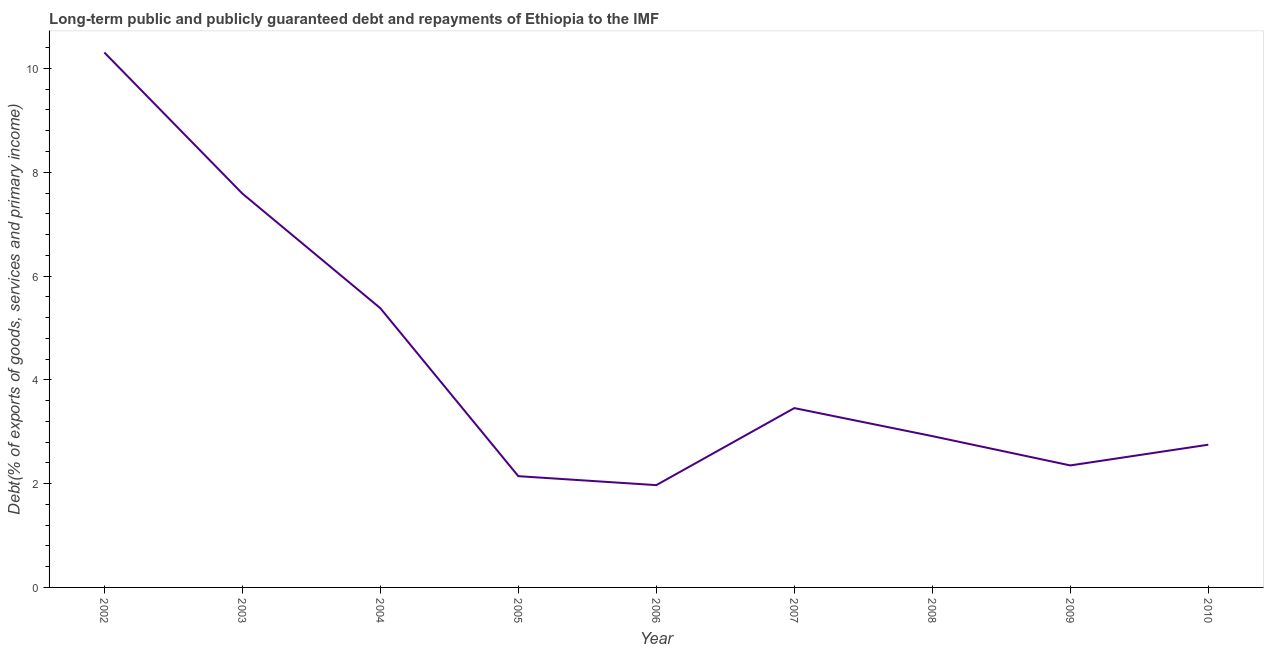What is the debt service in 2008?
Offer a terse response. 2.92. Across all years, what is the maximum debt service?
Make the answer very short. 10.31. Across all years, what is the minimum debt service?
Your answer should be very brief. 1.97. What is the sum of the debt service?
Provide a succinct answer. 38.87. What is the difference between the debt service in 2003 and 2009?
Provide a succinct answer. 5.24. What is the average debt service per year?
Your answer should be compact. 4.32. What is the median debt service?
Your response must be concise. 2.92. What is the ratio of the debt service in 2006 to that in 2009?
Keep it short and to the point. 0.84. What is the difference between the highest and the second highest debt service?
Give a very brief answer. 2.72. Is the sum of the debt service in 2005 and 2008 greater than the maximum debt service across all years?
Your answer should be compact. No. What is the difference between the highest and the lowest debt service?
Offer a terse response. 8.34. In how many years, is the debt service greater than the average debt service taken over all years?
Provide a short and direct response. 3. How many lines are there?
Provide a succinct answer. 1. How many years are there in the graph?
Give a very brief answer. 9. Are the values on the major ticks of Y-axis written in scientific E-notation?
Provide a short and direct response. No. Does the graph contain any zero values?
Offer a very short reply. No. What is the title of the graph?
Provide a succinct answer. Long-term public and publicly guaranteed debt and repayments of Ethiopia to the IMF. What is the label or title of the Y-axis?
Ensure brevity in your answer.  Debt(% of exports of goods, services and primary income). What is the Debt(% of exports of goods, services and primary income) of 2002?
Ensure brevity in your answer.  10.31. What is the Debt(% of exports of goods, services and primary income) of 2003?
Offer a very short reply. 7.59. What is the Debt(% of exports of goods, services and primary income) in 2004?
Offer a terse response. 5.38. What is the Debt(% of exports of goods, services and primary income) of 2005?
Make the answer very short. 2.14. What is the Debt(% of exports of goods, services and primary income) of 2006?
Ensure brevity in your answer.  1.97. What is the Debt(% of exports of goods, services and primary income) of 2007?
Keep it short and to the point. 3.46. What is the Debt(% of exports of goods, services and primary income) in 2008?
Provide a succinct answer. 2.92. What is the Debt(% of exports of goods, services and primary income) of 2009?
Your answer should be compact. 2.35. What is the Debt(% of exports of goods, services and primary income) in 2010?
Your answer should be very brief. 2.75. What is the difference between the Debt(% of exports of goods, services and primary income) in 2002 and 2003?
Offer a very short reply. 2.72. What is the difference between the Debt(% of exports of goods, services and primary income) in 2002 and 2004?
Provide a short and direct response. 4.93. What is the difference between the Debt(% of exports of goods, services and primary income) in 2002 and 2005?
Keep it short and to the point. 8.16. What is the difference between the Debt(% of exports of goods, services and primary income) in 2002 and 2006?
Provide a succinct answer. 8.34. What is the difference between the Debt(% of exports of goods, services and primary income) in 2002 and 2007?
Offer a terse response. 6.85. What is the difference between the Debt(% of exports of goods, services and primary income) in 2002 and 2008?
Provide a short and direct response. 7.39. What is the difference between the Debt(% of exports of goods, services and primary income) in 2002 and 2009?
Ensure brevity in your answer.  7.96. What is the difference between the Debt(% of exports of goods, services and primary income) in 2002 and 2010?
Your response must be concise. 7.56. What is the difference between the Debt(% of exports of goods, services and primary income) in 2003 and 2004?
Make the answer very short. 2.21. What is the difference between the Debt(% of exports of goods, services and primary income) in 2003 and 2005?
Ensure brevity in your answer.  5.45. What is the difference between the Debt(% of exports of goods, services and primary income) in 2003 and 2006?
Offer a very short reply. 5.62. What is the difference between the Debt(% of exports of goods, services and primary income) in 2003 and 2007?
Provide a short and direct response. 4.13. What is the difference between the Debt(% of exports of goods, services and primary income) in 2003 and 2008?
Your response must be concise. 4.67. What is the difference between the Debt(% of exports of goods, services and primary income) in 2003 and 2009?
Give a very brief answer. 5.24. What is the difference between the Debt(% of exports of goods, services and primary income) in 2003 and 2010?
Provide a succinct answer. 4.84. What is the difference between the Debt(% of exports of goods, services and primary income) in 2004 and 2005?
Your response must be concise. 3.24. What is the difference between the Debt(% of exports of goods, services and primary income) in 2004 and 2006?
Provide a succinct answer. 3.41. What is the difference between the Debt(% of exports of goods, services and primary income) in 2004 and 2007?
Offer a very short reply. 1.92. What is the difference between the Debt(% of exports of goods, services and primary income) in 2004 and 2008?
Provide a short and direct response. 2.46. What is the difference between the Debt(% of exports of goods, services and primary income) in 2004 and 2009?
Provide a short and direct response. 3.03. What is the difference between the Debt(% of exports of goods, services and primary income) in 2004 and 2010?
Ensure brevity in your answer.  2.63. What is the difference between the Debt(% of exports of goods, services and primary income) in 2005 and 2006?
Keep it short and to the point. 0.17. What is the difference between the Debt(% of exports of goods, services and primary income) in 2005 and 2007?
Keep it short and to the point. -1.31. What is the difference between the Debt(% of exports of goods, services and primary income) in 2005 and 2008?
Offer a terse response. -0.77. What is the difference between the Debt(% of exports of goods, services and primary income) in 2005 and 2009?
Your answer should be compact. -0.21. What is the difference between the Debt(% of exports of goods, services and primary income) in 2005 and 2010?
Give a very brief answer. -0.61. What is the difference between the Debt(% of exports of goods, services and primary income) in 2006 and 2007?
Your response must be concise. -1.48. What is the difference between the Debt(% of exports of goods, services and primary income) in 2006 and 2008?
Keep it short and to the point. -0.94. What is the difference between the Debt(% of exports of goods, services and primary income) in 2006 and 2009?
Provide a succinct answer. -0.38. What is the difference between the Debt(% of exports of goods, services and primary income) in 2006 and 2010?
Provide a short and direct response. -0.78. What is the difference between the Debt(% of exports of goods, services and primary income) in 2007 and 2008?
Offer a very short reply. 0.54. What is the difference between the Debt(% of exports of goods, services and primary income) in 2007 and 2009?
Offer a very short reply. 1.1. What is the difference between the Debt(% of exports of goods, services and primary income) in 2007 and 2010?
Ensure brevity in your answer.  0.71. What is the difference between the Debt(% of exports of goods, services and primary income) in 2008 and 2009?
Your answer should be very brief. 0.56. What is the difference between the Debt(% of exports of goods, services and primary income) in 2008 and 2010?
Your answer should be very brief. 0.17. What is the difference between the Debt(% of exports of goods, services and primary income) in 2009 and 2010?
Make the answer very short. -0.4. What is the ratio of the Debt(% of exports of goods, services and primary income) in 2002 to that in 2003?
Offer a very short reply. 1.36. What is the ratio of the Debt(% of exports of goods, services and primary income) in 2002 to that in 2004?
Provide a succinct answer. 1.92. What is the ratio of the Debt(% of exports of goods, services and primary income) in 2002 to that in 2005?
Offer a terse response. 4.81. What is the ratio of the Debt(% of exports of goods, services and primary income) in 2002 to that in 2006?
Keep it short and to the point. 5.23. What is the ratio of the Debt(% of exports of goods, services and primary income) in 2002 to that in 2007?
Make the answer very short. 2.98. What is the ratio of the Debt(% of exports of goods, services and primary income) in 2002 to that in 2008?
Offer a terse response. 3.54. What is the ratio of the Debt(% of exports of goods, services and primary income) in 2002 to that in 2009?
Make the answer very short. 4.38. What is the ratio of the Debt(% of exports of goods, services and primary income) in 2002 to that in 2010?
Offer a very short reply. 3.75. What is the ratio of the Debt(% of exports of goods, services and primary income) in 2003 to that in 2004?
Offer a terse response. 1.41. What is the ratio of the Debt(% of exports of goods, services and primary income) in 2003 to that in 2005?
Your answer should be compact. 3.54. What is the ratio of the Debt(% of exports of goods, services and primary income) in 2003 to that in 2006?
Your answer should be compact. 3.85. What is the ratio of the Debt(% of exports of goods, services and primary income) in 2003 to that in 2007?
Provide a succinct answer. 2.2. What is the ratio of the Debt(% of exports of goods, services and primary income) in 2003 to that in 2008?
Provide a short and direct response. 2.6. What is the ratio of the Debt(% of exports of goods, services and primary income) in 2003 to that in 2009?
Provide a short and direct response. 3.23. What is the ratio of the Debt(% of exports of goods, services and primary income) in 2003 to that in 2010?
Ensure brevity in your answer.  2.76. What is the ratio of the Debt(% of exports of goods, services and primary income) in 2004 to that in 2005?
Your answer should be very brief. 2.51. What is the ratio of the Debt(% of exports of goods, services and primary income) in 2004 to that in 2006?
Provide a succinct answer. 2.73. What is the ratio of the Debt(% of exports of goods, services and primary income) in 2004 to that in 2007?
Offer a very short reply. 1.56. What is the ratio of the Debt(% of exports of goods, services and primary income) in 2004 to that in 2008?
Provide a short and direct response. 1.84. What is the ratio of the Debt(% of exports of goods, services and primary income) in 2004 to that in 2009?
Offer a very short reply. 2.29. What is the ratio of the Debt(% of exports of goods, services and primary income) in 2004 to that in 2010?
Your answer should be compact. 1.96. What is the ratio of the Debt(% of exports of goods, services and primary income) in 2005 to that in 2006?
Make the answer very short. 1.09. What is the ratio of the Debt(% of exports of goods, services and primary income) in 2005 to that in 2007?
Ensure brevity in your answer.  0.62. What is the ratio of the Debt(% of exports of goods, services and primary income) in 2005 to that in 2008?
Keep it short and to the point. 0.73. What is the ratio of the Debt(% of exports of goods, services and primary income) in 2005 to that in 2009?
Your answer should be compact. 0.91. What is the ratio of the Debt(% of exports of goods, services and primary income) in 2005 to that in 2010?
Give a very brief answer. 0.78. What is the ratio of the Debt(% of exports of goods, services and primary income) in 2006 to that in 2007?
Your answer should be compact. 0.57. What is the ratio of the Debt(% of exports of goods, services and primary income) in 2006 to that in 2008?
Provide a succinct answer. 0.68. What is the ratio of the Debt(% of exports of goods, services and primary income) in 2006 to that in 2009?
Provide a succinct answer. 0.84. What is the ratio of the Debt(% of exports of goods, services and primary income) in 2006 to that in 2010?
Keep it short and to the point. 0.72. What is the ratio of the Debt(% of exports of goods, services and primary income) in 2007 to that in 2008?
Give a very brief answer. 1.19. What is the ratio of the Debt(% of exports of goods, services and primary income) in 2007 to that in 2009?
Offer a terse response. 1.47. What is the ratio of the Debt(% of exports of goods, services and primary income) in 2007 to that in 2010?
Offer a very short reply. 1.26. What is the ratio of the Debt(% of exports of goods, services and primary income) in 2008 to that in 2009?
Give a very brief answer. 1.24. What is the ratio of the Debt(% of exports of goods, services and primary income) in 2008 to that in 2010?
Ensure brevity in your answer.  1.06. What is the ratio of the Debt(% of exports of goods, services and primary income) in 2009 to that in 2010?
Provide a succinct answer. 0.85. 